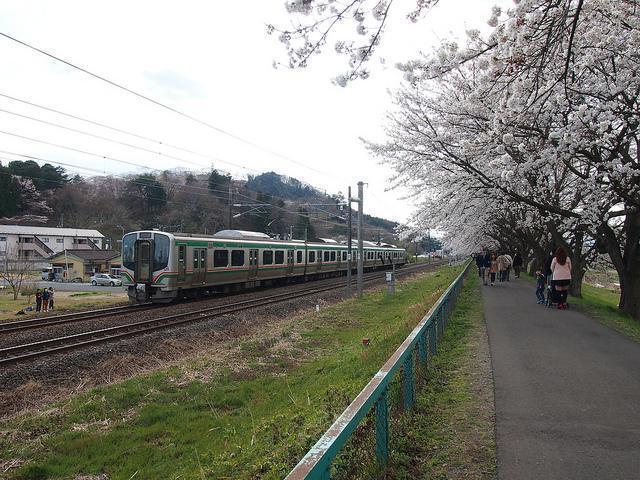What type of socks is the woman pushing the stroller wearing?
Choose the correct response and explain in the format: 'Answer: answer
Rationale: rationale.'
Options: Ankle, knee-high, white, crew cut. Answer: knee-high.
Rationale: A woman with socks that reach mid-leg height is walking along a path. 